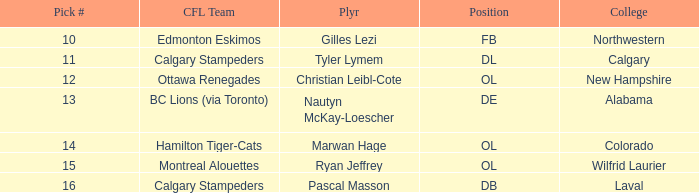What is the pick number for Northwestern college? 10.0. 